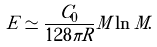Convert formula to latex. <formula><loc_0><loc_0><loc_500><loc_500>E \simeq \frac { C _ { 0 } } { 1 2 8 \pi R } M \ln M .</formula> 